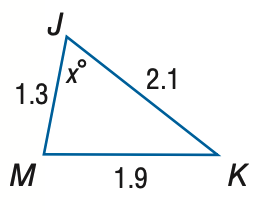Question: Find x. Round to the nearest degree.
Choices:
A. 43
B. 53
C. 63
D. 73
Answer with the letter. Answer: C 